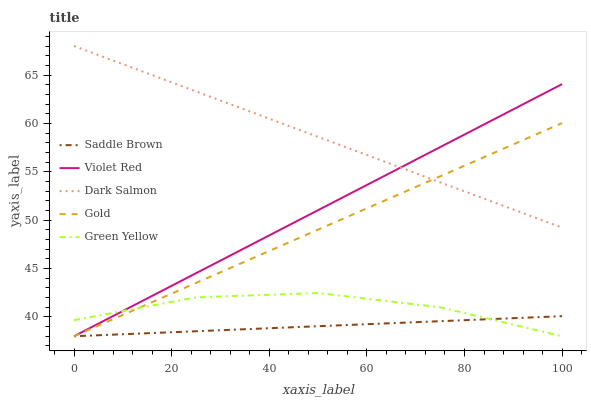Does Saddle Brown have the minimum area under the curve?
Answer yes or no. Yes. Does Dark Salmon have the maximum area under the curve?
Answer yes or no. Yes. Does Green Yellow have the minimum area under the curve?
Answer yes or no. No. Does Green Yellow have the maximum area under the curve?
Answer yes or no. No. Is Violet Red the smoothest?
Answer yes or no. Yes. Is Green Yellow the roughest?
Answer yes or no. Yes. Is Saddle Brown the smoothest?
Answer yes or no. No. Is Saddle Brown the roughest?
Answer yes or no. No. Does Dark Salmon have the lowest value?
Answer yes or no. No. Does Dark Salmon have the highest value?
Answer yes or no. Yes. Does Green Yellow have the highest value?
Answer yes or no. No. Is Green Yellow less than Dark Salmon?
Answer yes or no. Yes. Is Dark Salmon greater than Green Yellow?
Answer yes or no. Yes. Does Green Yellow intersect Saddle Brown?
Answer yes or no. Yes. Is Green Yellow less than Saddle Brown?
Answer yes or no. No. Is Green Yellow greater than Saddle Brown?
Answer yes or no. No. Does Green Yellow intersect Dark Salmon?
Answer yes or no. No. 